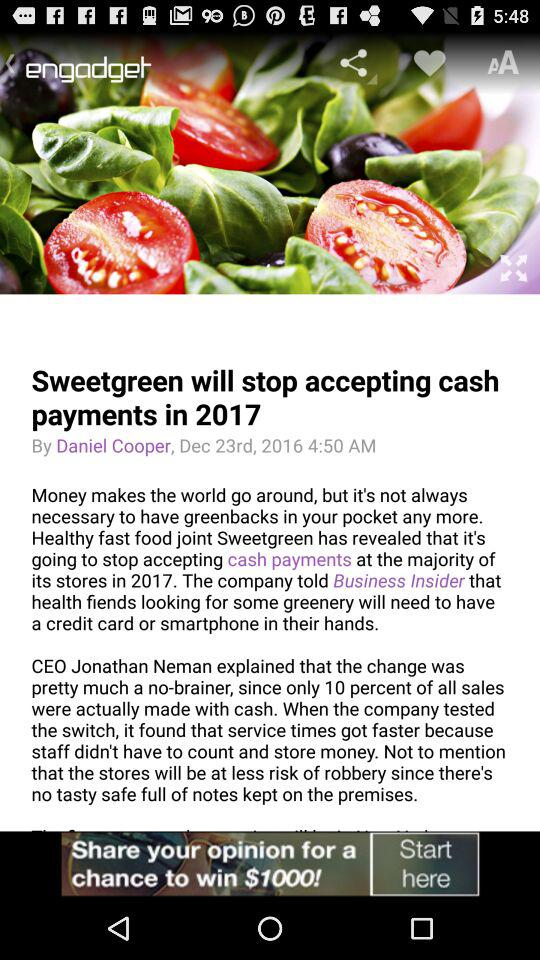What is the headline of article? The headline of the article is "Sweetgreen will stop accepting cash payments in 2017". 